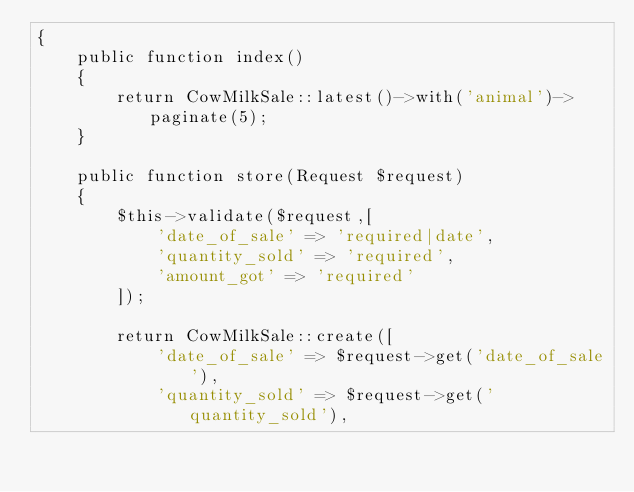<code> <loc_0><loc_0><loc_500><loc_500><_PHP_>{
    public function index()
    {
        return CowMilkSale::latest()->with('animal')->paginate(5);
    }
    
    public function store(Request $request)
    {
        $this->validate($request,[
            'date_of_sale' => 'required|date',
            'quantity_sold' => 'required',
            'amount_got' => 'required'
        ]);

        return CowMilkSale::create([
            'date_of_sale' => $request->get('date_of_sale'),
            'quantity_sold' => $request->get('quantity_sold'),</code> 